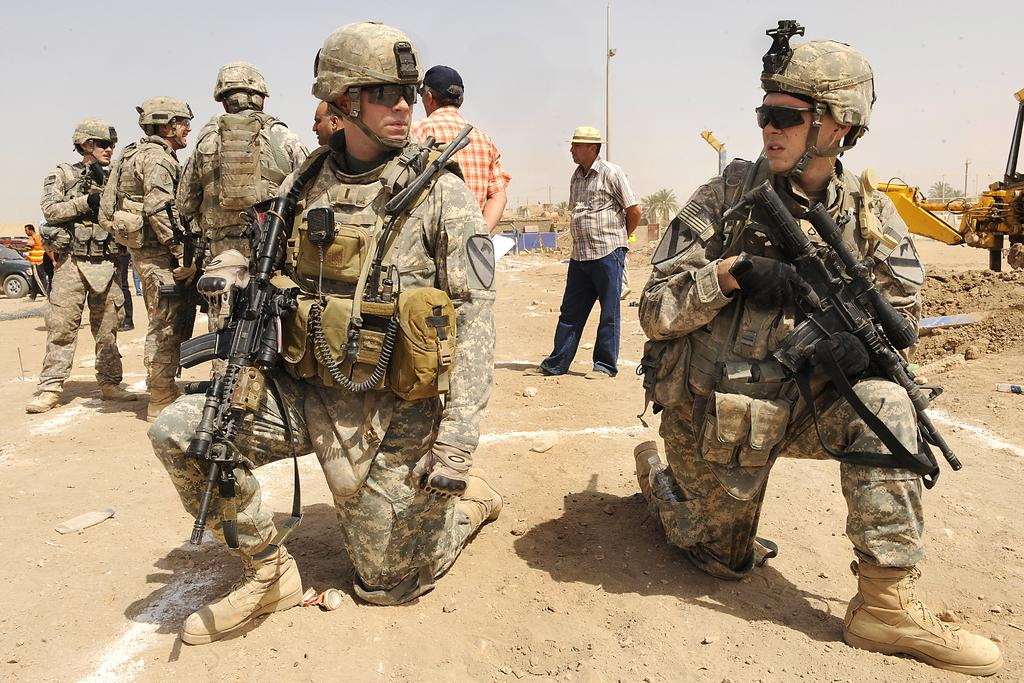How many people are in the group depicted in the image? There is a group of people in the image, but the exact number is not specified. What are some people in the group wearing? Some people in the group are wearing helmets. What are some people in the group holding? Some people in the group are holding guns. What can be seen in the background of the image? In the background of the image, there are vehicles, trees, poles, and buildings. What type of pest is causing problems for the people in the image? There is no indication of any pest in the image; it features a group of people and various background elements. Is there a jail visible in the image? There is no jail present in the image; it only shows a group of people and the background elements mentioned earlier. 